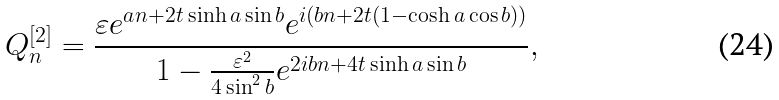Convert formula to latex. <formula><loc_0><loc_0><loc_500><loc_500>Q _ { n } ^ { [ 2 ] } = \frac { \varepsilon e ^ { a n + 2 t \sinh a \sin b } e ^ { i ( b n + 2 t ( 1 - \cosh a \cos b ) ) } } { 1 - \frac { \varepsilon ^ { 2 } } { 4 \sin ^ { 2 } b } e ^ { 2 i b n + 4 t \sinh a \sin b } } ,</formula> 